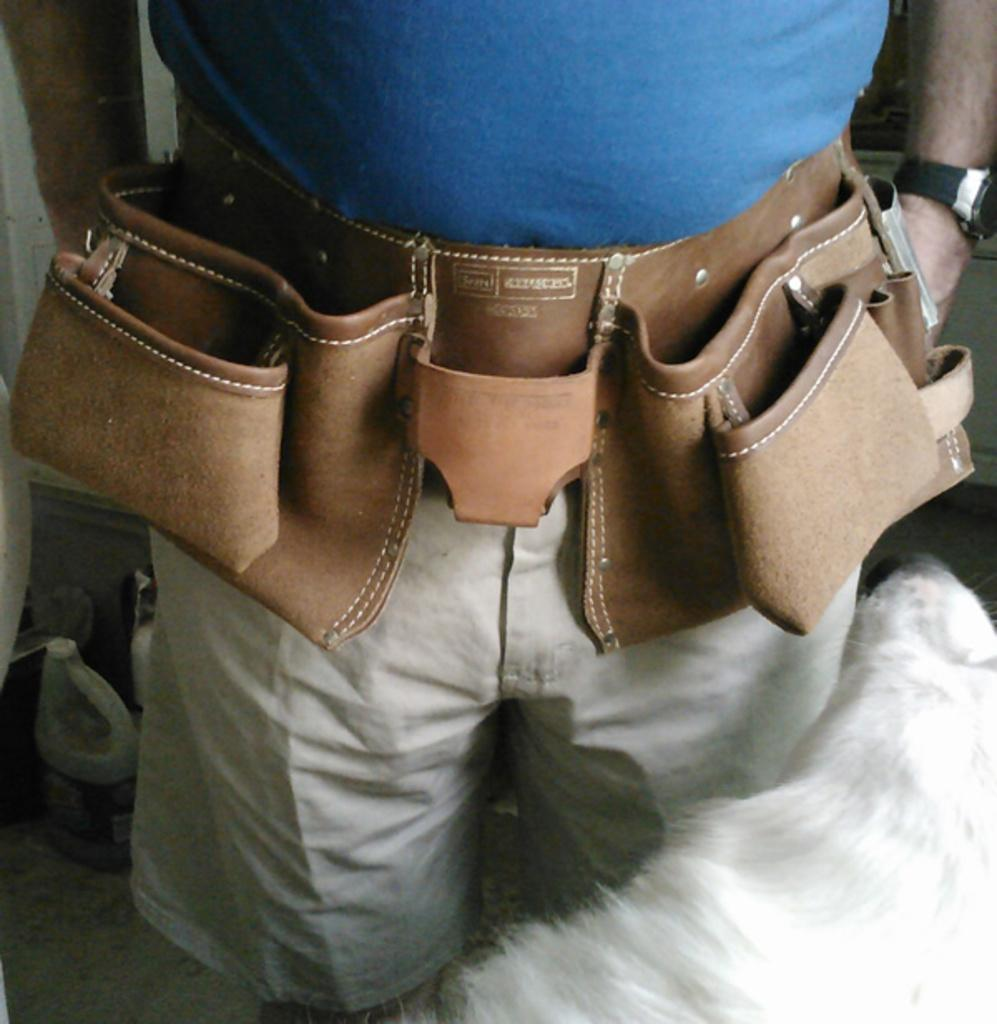What is the main subject of the image? There is a person in the image. What is the person wearing on their upper body? The person is wearing a blue top. What type of accessory is the person wearing around their waist? The person is wearing a tool belt. What type of clothing is the person wearing on their lower body? The person is wearing shorts. What type of accessory is the person wearing on their wrist? The person has a watch on their hand. Can you describe any objects visible in the background of the image? There are other objects visible in the background of the image, but their specific details are not mentioned in the provided facts. What type of current can be seen flowing through the person's leg in the image? There is no current flowing through the person's leg in the image; it is not mentioned in the provided facts. 